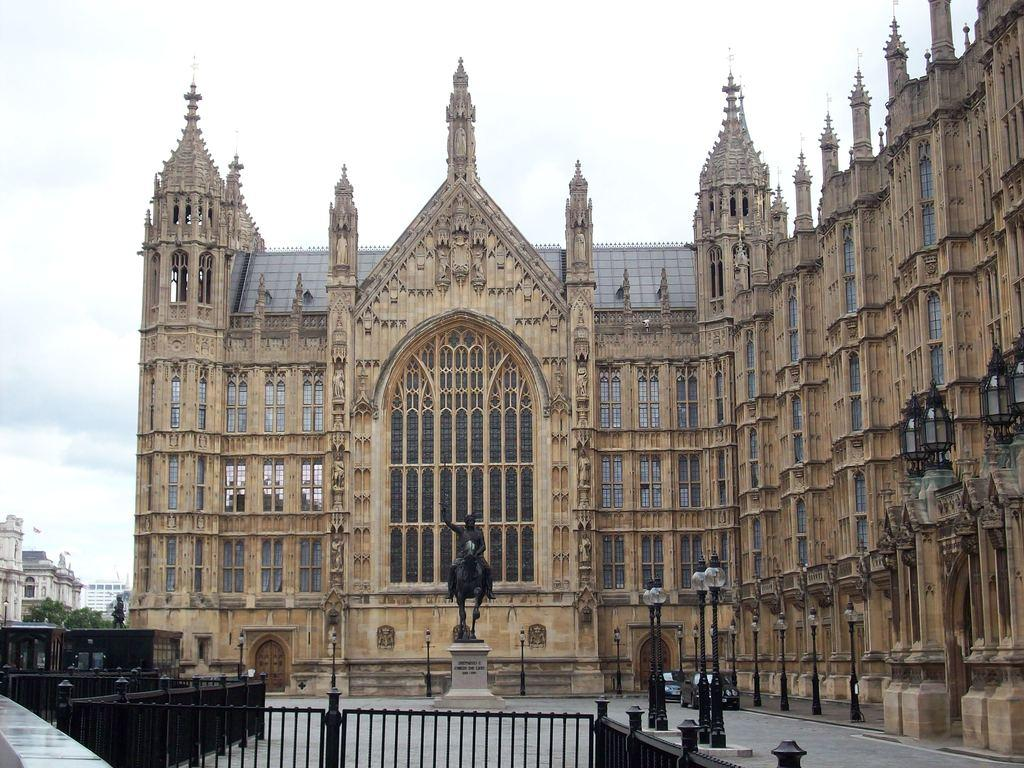What type of structure is present in the image? There is a building in the image. What vehicles can be seen in the image? There are two cars in the image. What other objects are present in the image? There are poles and a statue in the image. What is visible in the sky in the image? Clouds are visible in the sky. What type of insect can be seen crawling on the statue in the image? There is no insect present on the statue in the image. What is the tendency of the clouds to move in the image? The clouds do not have a tendency to move in the image, as they are a static representation of the sky. 